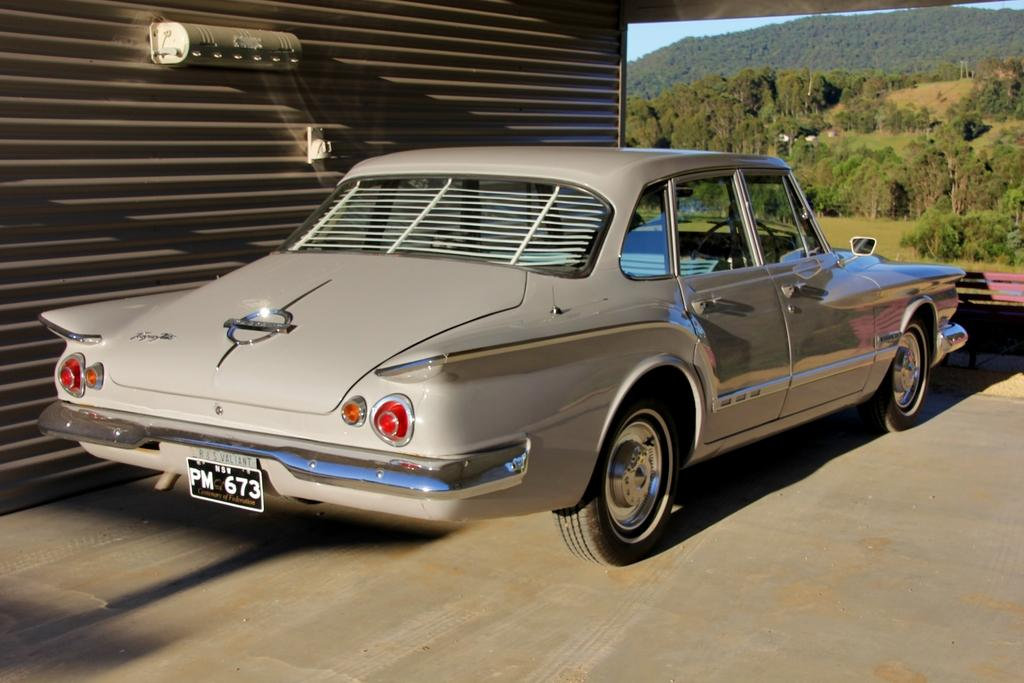What is the main subject of the image? The main subject of the image is a car. Can you describe the car's position in the image? The car is on a surface in the image. What can be seen on the shutter in the image? There is an object on a shutter in the image. What type of natural scenery is visible in the background of the image? There are trees, a mountain, and objects in the background of the image. What part of the sky is visible in the image? The sky is visible in the background of the image. How many oranges are hanging from the tree in the image? There are no oranges visible in the image; only trees and a mountain are present in the background. 